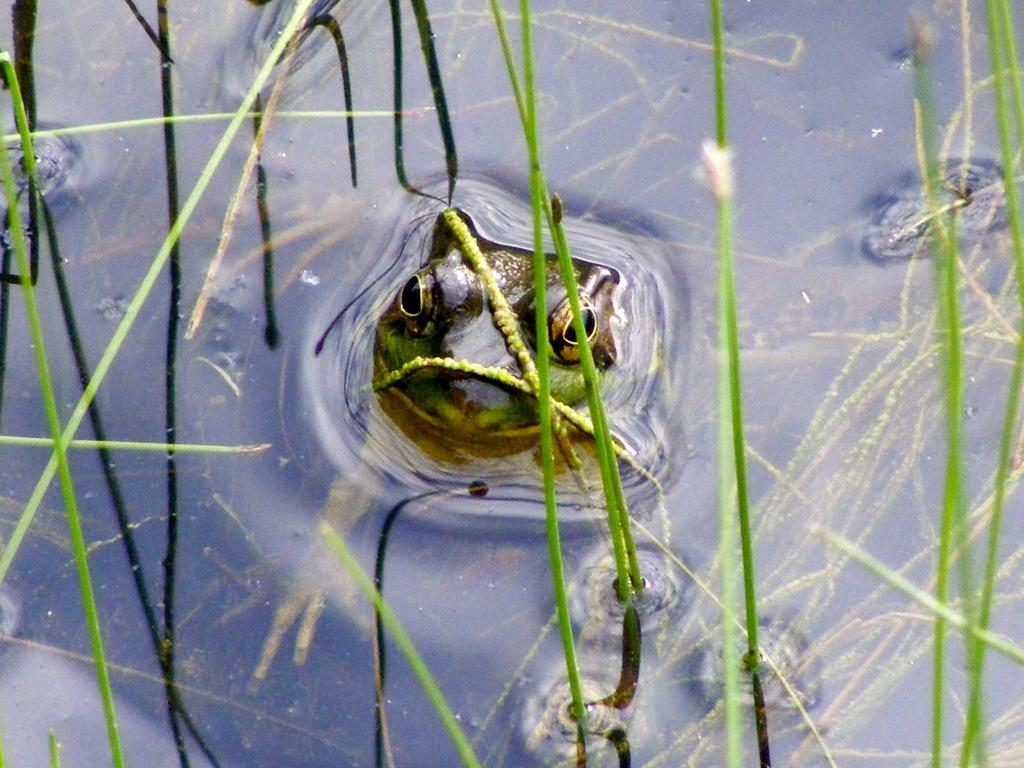What type of animal is in the image? There is a frog in the image. What colors can be seen on the frog? The frog has brown, green, and black colors. Where is the frog located in the image? The frog is in the water. What type of vegetation can be seen in the water? There is grass visible in the water. What type of news can be seen on the frog's back in the image? There is no news present in the image; it features a frog in the water with grass. 